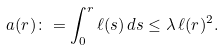Convert formula to latex. <formula><loc_0><loc_0><loc_500><loc_500>a ( r ) \colon = \int _ { 0 } ^ { r } \ell ( s ) \, d s \leq \lambda \, \ell ( r ) ^ { 2 } .</formula> 